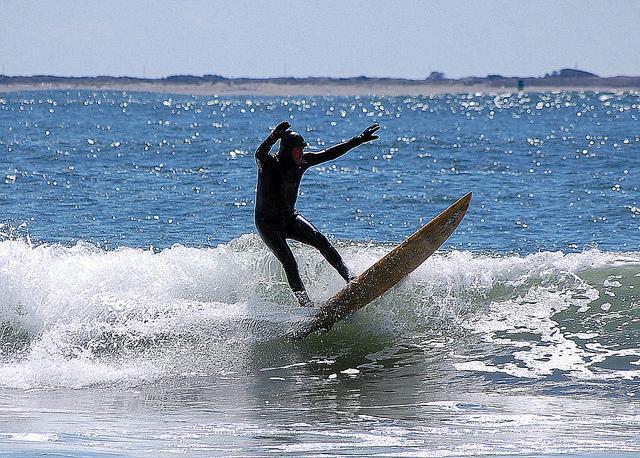How many buses are there?
Give a very brief answer. 0. 